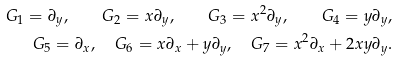<formula> <loc_0><loc_0><loc_500><loc_500>G _ { 1 } = \partial _ { y } , \quad G _ { 2 } = x \partial _ { y } , \quad G _ { 3 } = x ^ { 2 } \partial _ { y } , \quad G _ { 4 } = y \partial _ { y } , \\ G _ { 5 } = \partial _ { x } , \quad G _ { 6 } = x \partial _ { x } + y \partial _ { y } , \quad G _ { 7 } = x ^ { 2 } \partial _ { x } + 2 x y \partial _ { y } .</formula> 